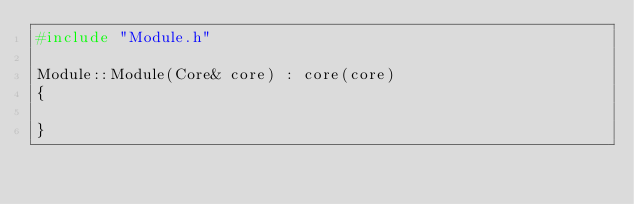<code> <loc_0><loc_0><loc_500><loc_500><_C++_>#include "Module.h"

Module::Module(Core& core) : core(core)
{

}
</code> 